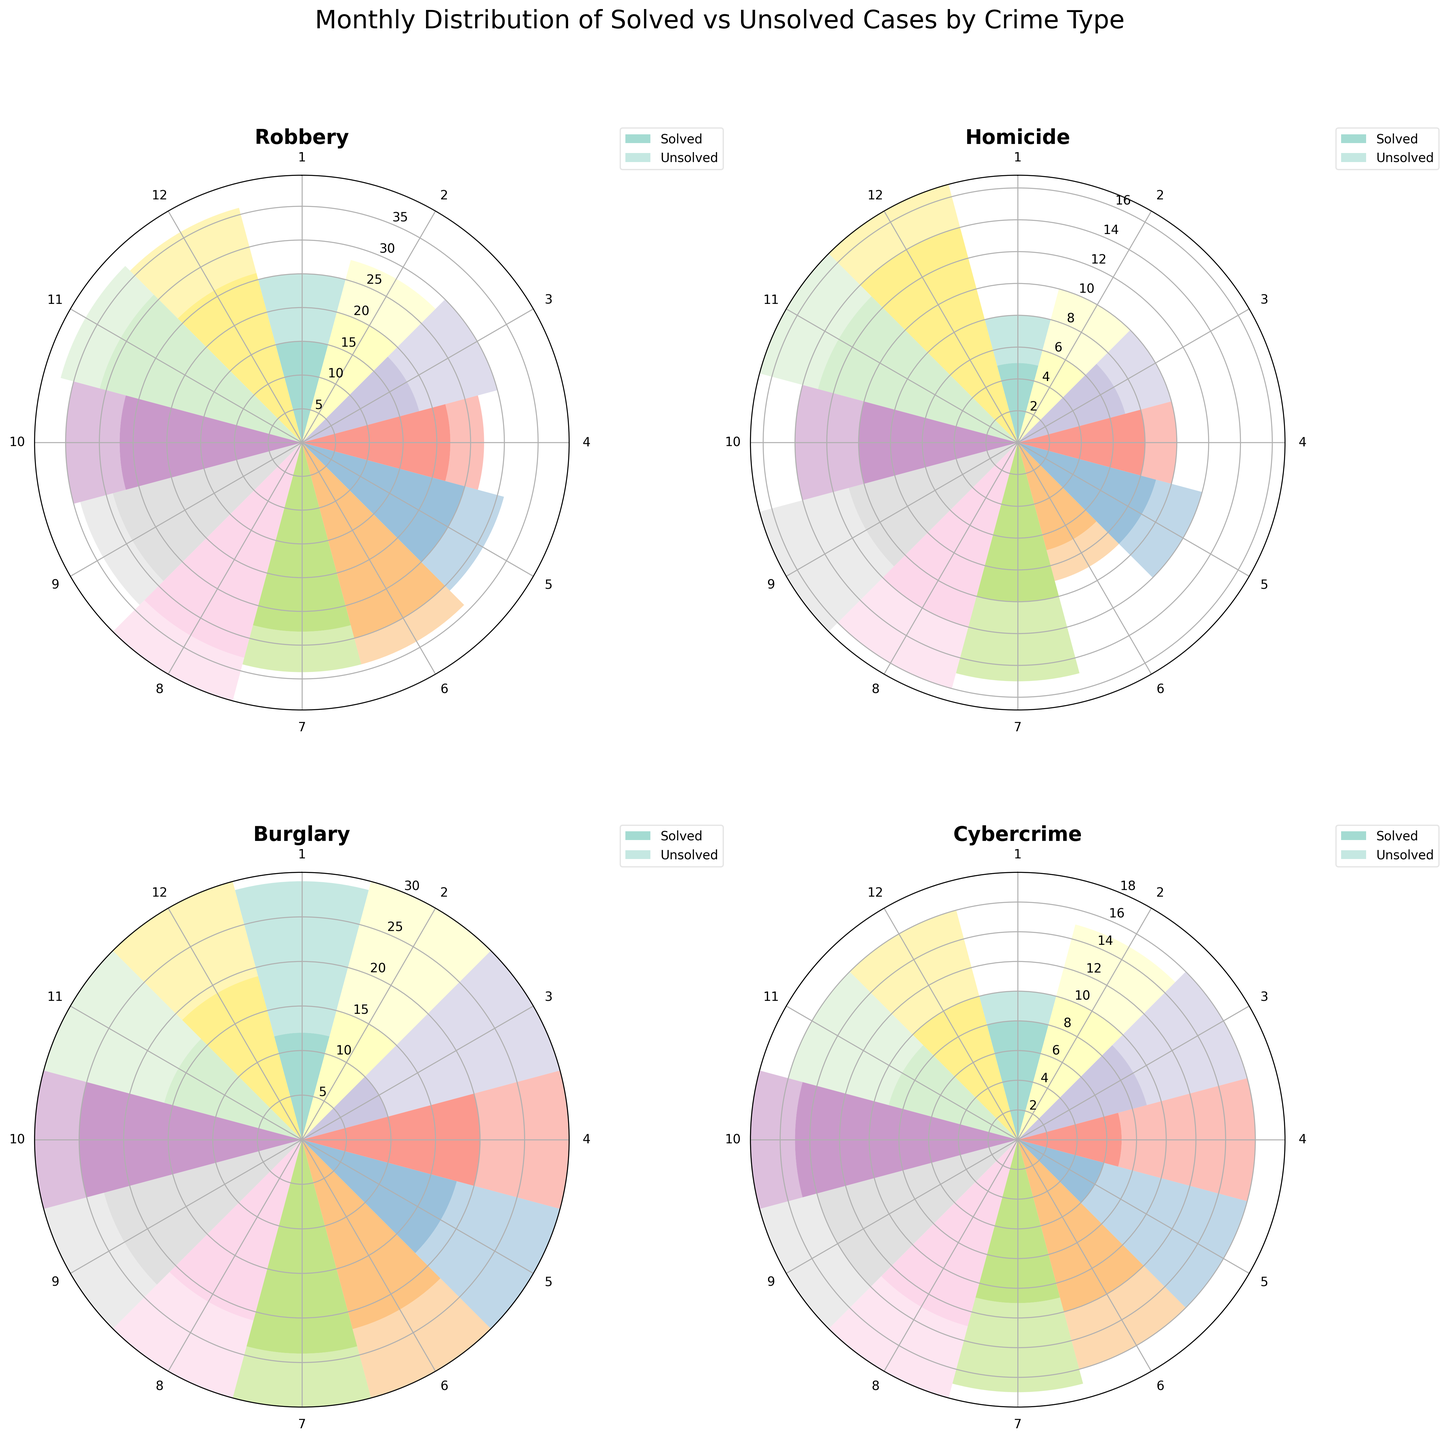What's the title of the figure? The title is located at the top of the figure and indicates what the figure represents.
Answer: Monthly Distribution of Solved vs Unsolved Cases by Crime Type Which month in the Robbery subplot has the highest number of solved cases? To find the month with the highest number of solved cases in the Robbery subplot, look at the radial bars and identify the one with the maximum length.
Answer: August How many solved and unsolved Burglary cases are there in March? Locate the Burglary subplot and look at the values for March. The bar heights represent the count of solved and unsolved cases. The solved cases are shown at the bottom part of the combined bar, and unsolved cases are stacked on top.
Answer: Solved: 10, Unsolved: 25 Compare the number of solved cases in Homicide between May and November. Which month has more? Look at the Homicide subplot and compare the bar heights for May and November. The solved cases are represented by the lower segment of the bars.
Answer: November Which crime type shows the least variation in monthly solved cases? Evaluate the subplots for each crime type and look for the subplot where the solved cases bars have a relatively consistent height month-to-month.
Answer: Homicide For Cybercrime, which month has the highest number of unsolved cases? In the Cybercrime subplot, examine the upper parts of the bars for each month to find the one with the highest value representing unsolved cases.
Answer: October What is the combined total of solved and unsolved Robbery cases in June? In the Robbery subplot, find June and sum the height of the solved and unsolved cases bars together.
Answer: 34 In which months do solved Burglary cases exceed unsolved cases? Refer to the Burglary subplot and identify the months where the bottom part of the bar (solved cases) is taller than the top part (unsolved cases).
Answer: January, April, June, July, September Is there any month where Cybercrime cases (solved + unsolved) exceed 20 cases? For each month in the Cybercrime subplot, add the solved and unsolved cases and check if any month exceeds 20 cases.
Answer: No Compare the trend of solved Robbery cases from January to December. Does it show an increase, decrease, or random pattern? Analyze the heights of the solved cases bars in the Robbery subplot from January to December to determine if there is a consistent trend.
Answer: Increase 